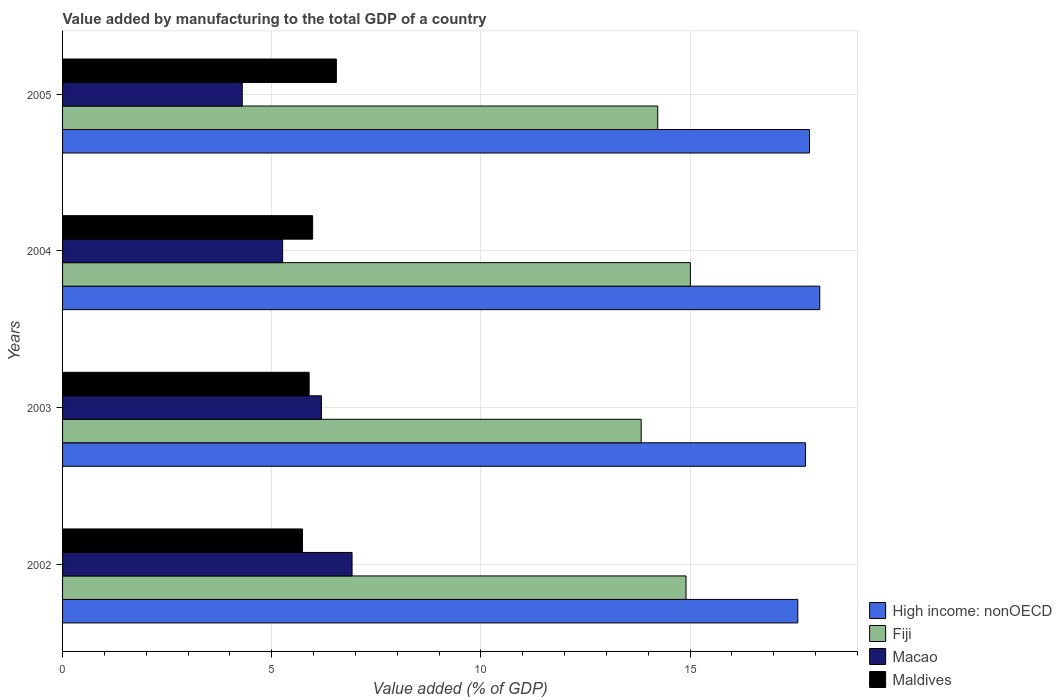How many different coloured bars are there?
Provide a succinct answer. 4. Are the number of bars per tick equal to the number of legend labels?
Your answer should be compact. Yes. Are the number of bars on each tick of the Y-axis equal?
Offer a very short reply. Yes. How many bars are there on the 1st tick from the top?
Provide a short and direct response. 4. How many bars are there on the 1st tick from the bottom?
Provide a short and direct response. 4. What is the value added by manufacturing to the total GDP in Maldives in 2005?
Provide a short and direct response. 6.54. Across all years, what is the maximum value added by manufacturing to the total GDP in Maldives?
Your response must be concise. 6.54. Across all years, what is the minimum value added by manufacturing to the total GDP in Fiji?
Ensure brevity in your answer.  13.83. In which year was the value added by manufacturing to the total GDP in Macao minimum?
Make the answer very short. 2005. What is the total value added by manufacturing to the total GDP in Fiji in the graph?
Your answer should be very brief. 57.97. What is the difference between the value added by manufacturing to the total GDP in Maldives in 2002 and that in 2003?
Ensure brevity in your answer.  -0.16. What is the difference between the value added by manufacturing to the total GDP in High income: nonOECD in 2003 and the value added by manufacturing to the total GDP in Maldives in 2002?
Give a very brief answer. 12.03. What is the average value added by manufacturing to the total GDP in Maldives per year?
Offer a very short reply. 6.04. In the year 2003, what is the difference between the value added by manufacturing to the total GDP in High income: nonOECD and value added by manufacturing to the total GDP in Macao?
Your answer should be very brief. 11.57. In how many years, is the value added by manufacturing to the total GDP in High income: nonOECD greater than 17 %?
Ensure brevity in your answer.  4. What is the ratio of the value added by manufacturing to the total GDP in Maldives in 2003 to that in 2004?
Your answer should be very brief. 0.99. Is the value added by manufacturing to the total GDP in High income: nonOECD in 2003 less than that in 2005?
Offer a terse response. Yes. What is the difference between the highest and the second highest value added by manufacturing to the total GDP in Macao?
Keep it short and to the point. 0.73. What is the difference between the highest and the lowest value added by manufacturing to the total GDP in Macao?
Give a very brief answer. 2.62. In how many years, is the value added by manufacturing to the total GDP in Maldives greater than the average value added by manufacturing to the total GDP in Maldives taken over all years?
Keep it short and to the point. 1. What does the 3rd bar from the top in 2005 represents?
Make the answer very short. Fiji. What does the 3rd bar from the bottom in 2003 represents?
Your response must be concise. Macao. Are all the bars in the graph horizontal?
Your response must be concise. Yes. How many years are there in the graph?
Your answer should be compact. 4. Are the values on the major ticks of X-axis written in scientific E-notation?
Provide a short and direct response. No. Does the graph contain any zero values?
Provide a short and direct response. No. What is the title of the graph?
Ensure brevity in your answer.  Value added by manufacturing to the total GDP of a country. Does "Turkmenistan" appear as one of the legend labels in the graph?
Your response must be concise. No. What is the label or title of the X-axis?
Provide a short and direct response. Value added (% of GDP). What is the Value added (% of GDP) of High income: nonOECD in 2002?
Make the answer very short. 17.58. What is the Value added (% of GDP) of Fiji in 2002?
Provide a succinct answer. 14.9. What is the Value added (% of GDP) of Macao in 2002?
Give a very brief answer. 6.92. What is the Value added (% of GDP) in Maldives in 2002?
Your answer should be very brief. 5.73. What is the Value added (% of GDP) in High income: nonOECD in 2003?
Make the answer very short. 17.76. What is the Value added (% of GDP) in Fiji in 2003?
Keep it short and to the point. 13.83. What is the Value added (% of GDP) in Macao in 2003?
Offer a terse response. 6.19. What is the Value added (% of GDP) of Maldives in 2003?
Make the answer very short. 5.89. What is the Value added (% of GDP) of High income: nonOECD in 2004?
Your answer should be very brief. 18.1. What is the Value added (% of GDP) in Fiji in 2004?
Your response must be concise. 15.01. What is the Value added (% of GDP) of Macao in 2004?
Your answer should be compact. 5.26. What is the Value added (% of GDP) in Maldives in 2004?
Offer a very short reply. 5.98. What is the Value added (% of GDP) of High income: nonOECD in 2005?
Make the answer very short. 17.86. What is the Value added (% of GDP) of Fiji in 2005?
Offer a terse response. 14.23. What is the Value added (% of GDP) of Macao in 2005?
Offer a terse response. 4.3. What is the Value added (% of GDP) of Maldives in 2005?
Offer a very short reply. 6.54. Across all years, what is the maximum Value added (% of GDP) of High income: nonOECD?
Your response must be concise. 18.1. Across all years, what is the maximum Value added (% of GDP) of Fiji?
Ensure brevity in your answer.  15.01. Across all years, what is the maximum Value added (% of GDP) in Macao?
Your answer should be compact. 6.92. Across all years, what is the maximum Value added (% of GDP) of Maldives?
Your response must be concise. 6.54. Across all years, what is the minimum Value added (% of GDP) in High income: nonOECD?
Offer a very short reply. 17.58. Across all years, what is the minimum Value added (% of GDP) in Fiji?
Offer a very short reply. 13.83. Across all years, what is the minimum Value added (% of GDP) in Macao?
Keep it short and to the point. 4.3. Across all years, what is the minimum Value added (% of GDP) of Maldives?
Your response must be concise. 5.73. What is the total Value added (% of GDP) in High income: nonOECD in the graph?
Offer a very short reply. 71.29. What is the total Value added (% of GDP) of Fiji in the graph?
Ensure brevity in your answer.  57.97. What is the total Value added (% of GDP) of Macao in the graph?
Provide a succinct answer. 22.66. What is the total Value added (% of GDP) of Maldives in the graph?
Make the answer very short. 24.15. What is the difference between the Value added (% of GDP) of High income: nonOECD in 2002 and that in 2003?
Your answer should be very brief. -0.18. What is the difference between the Value added (% of GDP) in Fiji in 2002 and that in 2003?
Offer a very short reply. 1.07. What is the difference between the Value added (% of GDP) of Macao in 2002 and that in 2003?
Keep it short and to the point. 0.73. What is the difference between the Value added (% of GDP) of Maldives in 2002 and that in 2003?
Your answer should be very brief. -0.16. What is the difference between the Value added (% of GDP) of High income: nonOECD in 2002 and that in 2004?
Offer a very short reply. -0.52. What is the difference between the Value added (% of GDP) of Fiji in 2002 and that in 2004?
Your answer should be compact. -0.1. What is the difference between the Value added (% of GDP) in Macao in 2002 and that in 2004?
Ensure brevity in your answer.  1.66. What is the difference between the Value added (% of GDP) of Maldives in 2002 and that in 2004?
Ensure brevity in your answer.  -0.24. What is the difference between the Value added (% of GDP) of High income: nonOECD in 2002 and that in 2005?
Your response must be concise. -0.28. What is the difference between the Value added (% of GDP) of Fiji in 2002 and that in 2005?
Provide a short and direct response. 0.68. What is the difference between the Value added (% of GDP) in Macao in 2002 and that in 2005?
Offer a terse response. 2.62. What is the difference between the Value added (% of GDP) of Maldives in 2002 and that in 2005?
Make the answer very short. -0.81. What is the difference between the Value added (% of GDP) in High income: nonOECD in 2003 and that in 2004?
Offer a very short reply. -0.34. What is the difference between the Value added (% of GDP) in Fiji in 2003 and that in 2004?
Provide a succinct answer. -1.18. What is the difference between the Value added (% of GDP) of Macao in 2003 and that in 2004?
Keep it short and to the point. 0.93. What is the difference between the Value added (% of GDP) in Maldives in 2003 and that in 2004?
Provide a short and direct response. -0.08. What is the difference between the Value added (% of GDP) of High income: nonOECD in 2003 and that in 2005?
Offer a very short reply. -0.1. What is the difference between the Value added (% of GDP) of Fiji in 2003 and that in 2005?
Make the answer very short. -0.4. What is the difference between the Value added (% of GDP) in Macao in 2003 and that in 2005?
Offer a very short reply. 1.89. What is the difference between the Value added (% of GDP) of Maldives in 2003 and that in 2005?
Ensure brevity in your answer.  -0.65. What is the difference between the Value added (% of GDP) of High income: nonOECD in 2004 and that in 2005?
Give a very brief answer. 0.24. What is the difference between the Value added (% of GDP) in Fiji in 2004 and that in 2005?
Your response must be concise. 0.78. What is the difference between the Value added (% of GDP) of Macao in 2004 and that in 2005?
Your answer should be very brief. 0.97. What is the difference between the Value added (% of GDP) in Maldives in 2004 and that in 2005?
Keep it short and to the point. -0.57. What is the difference between the Value added (% of GDP) in High income: nonOECD in 2002 and the Value added (% of GDP) in Fiji in 2003?
Keep it short and to the point. 3.74. What is the difference between the Value added (% of GDP) of High income: nonOECD in 2002 and the Value added (% of GDP) of Macao in 2003?
Offer a very short reply. 11.39. What is the difference between the Value added (% of GDP) of High income: nonOECD in 2002 and the Value added (% of GDP) of Maldives in 2003?
Provide a succinct answer. 11.68. What is the difference between the Value added (% of GDP) in Fiji in 2002 and the Value added (% of GDP) in Macao in 2003?
Provide a succinct answer. 8.72. What is the difference between the Value added (% of GDP) in Fiji in 2002 and the Value added (% of GDP) in Maldives in 2003?
Offer a terse response. 9.01. What is the difference between the Value added (% of GDP) of Macao in 2002 and the Value added (% of GDP) of Maldives in 2003?
Make the answer very short. 1.03. What is the difference between the Value added (% of GDP) of High income: nonOECD in 2002 and the Value added (% of GDP) of Fiji in 2004?
Ensure brevity in your answer.  2.57. What is the difference between the Value added (% of GDP) in High income: nonOECD in 2002 and the Value added (% of GDP) in Macao in 2004?
Offer a very short reply. 12.31. What is the difference between the Value added (% of GDP) of High income: nonOECD in 2002 and the Value added (% of GDP) of Maldives in 2004?
Your answer should be compact. 11.6. What is the difference between the Value added (% of GDP) of Fiji in 2002 and the Value added (% of GDP) of Macao in 2004?
Your response must be concise. 9.64. What is the difference between the Value added (% of GDP) in Fiji in 2002 and the Value added (% of GDP) in Maldives in 2004?
Make the answer very short. 8.93. What is the difference between the Value added (% of GDP) in Macao in 2002 and the Value added (% of GDP) in Maldives in 2004?
Your answer should be compact. 0.94. What is the difference between the Value added (% of GDP) in High income: nonOECD in 2002 and the Value added (% of GDP) in Fiji in 2005?
Ensure brevity in your answer.  3.35. What is the difference between the Value added (% of GDP) of High income: nonOECD in 2002 and the Value added (% of GDP) of Macao in 2005?
Your answer should be compact. 13.28. What is the difference between the Value added (% of GDP) of High income: nonOECD in 2002 and the Value added (% of GDP) of Maldives in 2005?
Provide a succinct answer. 11.03. What is the difference between the Value added (% of GDP) in Fiji in 2002 and the Value added (% of GDP) in Macao in 2005?
Your answer should be very brief. 10.61. What is the difference between the Value added (% of GDP) in Fiji in 2002 and the Value added (% of GDP) in Maldives in 2005?
Make the answer very short. 8.36. What is the difference between the Value added (% of GDP) in Macao in 2002 and the Value added (% of GDP) in Maldives in 2005?
Your response must be concise. 0.38. What is the difference between the Value added (% of GDP) in High income: nonOECD in 2003 and the Value added (% of GDP) in Fiji in 2004?
Provide a succinct answer. 2.75. What is the difference between the Value added (% of GDP) of High income: nonOECD in 2003 and the Value added (% of GDP) of Macao in 2004?
Provide a succinct answer. 12.5. What is the difference between the Value added (% of GDP) of High income: nonOECD in 2003 and the Value added (% of GDP) of Maldives in 2004?
Your response must be concise. 11.78. What is the difference between the Value added (% of GDP) of Fiji in 2003 and the Value added (% of GDP) of Macao in 2004?
Your answer should be very brief. 8.57. What is the difference between the Value added (% of GDP) in Fiji in 2003 and the Value added (% of GDP) in Maldives in 2004?
Keep it short and to the point. 7.85. What is the difference between the Value added (% of GDP) of Macao in 2003 and the Value added (% of GDP) of Maldives in 2004?
Your answer should be compact. 0.21. What is the difference between the Value added (% of GDP) in High income: nonOECD in 2003 and the Value added (% of GDP) in Fiji in 2005?
Offer a very short reply. 3.53. What is the difference between the Value added (% of GDP) of High income: nonOECD in 2003 and the Value added (% of GDP) of Macao in 2005?
Ensure brevity in your answer.  13.46. What is the difference between the Value added (% of GDP) in High income: nonOECD in 2003 and the Value added (% of GDP) in Maldives in 2005?
Make the answer very short. 11.21. What is the difference between the Value added (% of GDP) in Fiji in 2003 and the Value added (% of GDP) in Macao in 2005?
Keep it short and to the point. 9.54. What is the difference between the Value added (% of GDP) of Fiji in 2003 and the Value added (% of GDP) of Maldives in 2005?
Give a very brief answer. 7.29. What is the difference between the Value added (% of GDP) in Macao in 2003 and the Value added (% of GDP) in Maldives in 2005?
Offer a very short reply. -0.36. What is the difference between the Value added (% of GDP) of High income: nonOECD in 2004 and the Value added (% of GDP) of Fiji in 2005?
Make the answer very short. 3.87. What is the difference between the Value added (% of GDP) of High income: nonOECD in 2004 and the Value added (% of GDP) of Macao in 2005?
Make the answer very short. 13.8. What is the difference between the Value added (% of GDP) in High income: nonOECD in 2004 and the Value added (% of GDP) in Maldives in 2005?
Your answer should be compact. 11.56. What is the difference between the Value added (% of GDP) in Fiji in 2004 and the Value added (% of GDP) in Macao in 2005?
Provide a succinct answer. 10.71. What is the difference between the Value added (% of GDP) of Fiji in 2004 and the Value added (% of GDP) of Maldives in 2005?
Your answer should be very brief. 8.46. What is the difference between the Value added (% of GDP) in Macao in 2004 and the Value added (% of GDP) in Maldives in 2005?
Provide a succinct answer. -1.28. What is the average Value added (% of GDP) of High income: nonOECD per year?
Your answer should be compact. 17.82. What is the average Value added (% of GDP) of Fiji per year?
Offer a terse response. 14.49. What is the average Value added (% of GDP) in Macao per year?
Your answer should be very brief. 5.67. What is the average Value added (% of GDP) in Maldives per year?
Keep it short and to the point. 6.04. In the year 2002, what is the difference between the Value added (% of GDP) of High income: nonOECD and Value added (% of GDP) of Fiji?
Provide a succinct answer. 2.67. In the year 2002, what is the difference between the Value added (% of GDP) of High income: nonOECD and Value added (% of GDP) of Macao?
Your answer should be very brief. 10.65. In the year 2002, what is the difference between the Value added (% of GDP) in High income: nonOECD and Value added (% of GDP) in Maldives?
Provide a short and direct response. 11.84. In the year 2002, what is the difference between the Value added (% of GDP) in Fiji and Value added (% of GDP) in Macao?
Your answer should be very brief. 7.98. In the year 2002, what is the difference between the Value added (% of GDP) in Fiji and Value added (% of GDP) in Maldives?
Make the answer very short. 9.17. In the year 2002, what is the difference between the Value added (% of GDP) of Macao and Value added (% of GDP) of Maldives?
Provide a short and direct response. 1.19. In the year 2003, what is the difference between the Value added (% of GDP) of High income: nonOECD and Value added (% of GDP) of Fiji?
Make the answer very short. 3.93. In the year 2003, what is the difference between the Value added (% of GDP) of High income: nonOECD and Value added (% of GDP) of Macao?
Your answer should be compact. 11.57. In the year 2003, what is the difference between the Value added (% of GDP) in High income: nonOECD and Value added (% of GDP) in Maldives?
Your response must be concise. 11.87. In the year 2003, what is the difference between the Value added (% of GDP) of Fiji and Value added (% of GDP) of Macao?
Offer a terse response. 7.64. In the year 2003, what is the difference between the Value added (% of GDP) in Fiji and Value added (% of GDP) in Maldives?
Your response must be concise. 7.94. In the year 2003, what is the difference between the Value added (% of GDP) of Macao and Value added (% of GDP) of Maldives?
Offer a very short reply. 0.29. In the year 2004, what is the difference between the Value added (% of GDP) of High income: nonOECD and Value added (% of GDP) of Fiji?
Give a very brief answer. 3.09. In the year 2004, what is the difference between the Value added (% of GDP) of High income: nonOECD and Value added (% of GDP) of Macao?
Offer a terse response. 12.84. In the year 2004, what is the difference between the Value added (% of GDP) of High income: nonOECD and Value added (% of GDP) of Maldives?
Offer a very short reply. 12.12. In the year 2004, what is the difference between the Value added (% of GDP) in Fiji and Value added (% of GDP) in Macao?
Keep it short and to the point. 9.75. In the year 2004, what is the difference between the Value added (% of GDP) in Fiji and Value added (% of GDP) in Maldives?
Ensure brevity in your answer.  9.03. In the year 2004, what is the difference between the Value added (% of GDP) in Macao and Value added (% of GDP) in Maldives?
Keep it short and to the point. -0.72. In the year 2005, what is the difference between the Value added (% of GDP) in High income: nonOECD and Value added (% of GDP) in Fiji?
Ensure brevity in your answer.  3.63. In the year 2005, what is the difference between the Value added (% of GDP) of High income: nonOECD and Value added (% of GDP) of Macao?
Provide a succinct answer. 13.56. In the year 2005, what is the difference between the Value added (% of GDP) of High income: nonOECD and Value added (% of GDP) of Maldives?
Your answer should be compact. 11.31. In the year 2005, what is the difference between the Value added (% of GDP) of Fiji and Value added (% of GDP) of Macao?
Keep it short and to the point. 9.93. In the year 2005, what is the difference between the Value added (% of GDP) of Fiji and Value added (% of GDP) of Maldives?
Offer a terse response. 7.68. In the year 2005, what is the difference between the Value added (% of GDP) in Macao and Value added (% of GDP) in Maldives?
Provide a succinct answer. -2.25. What is the ratio of the Value added (% of GDP) of High income: nonOECD in 2002 to that in 2003?
Offer a very short reply. 0.99. What is the ratio of the Value added (% of GDP) of Fiji in 2002 to that in 2003?
Provide a succinct answer. 1.08. What is the ratio of the Value added (% of GDP) of Macao in 2002 to that in 2003?
Your response must be concise. 1.12. What is the ratio of the Value added (% of GDP) in Maldives in 2002 to that in 2003?
Give a very brief answer. 0.97. What is the ratio of the Value added (% of GDP) of High income: nonOECD in 2002 to that in 2004?
Make the answer very short. 0.97. What is the ratio of the Value added (% of GDP) in Fiji in 2002 to that in 2004?
Ensure brevity in your answer.  0.99. What is the ratio of the Value added (% of GDP) of Macao in 2002 to that in 2004?
Provide a short and direct response. 1.32. What is the ratio of the Value added (% of GDP) in Maldives in 2002 to that in 2004?
Make the answer very short. 0.96. What is the ratio of the Value added (% of GDP) of High income: nonOECD in 2002 to that in 2005?
Your response must be concise. 0.98. What is the ratio of the Value added (% of GDP) of Fiji in 2002 to that in 2005?
Offer a very short reply. 1.05. What is the ratio of the Value added (% of GDP) of Macao in 2002 to that in 2005?
Keep it short and to the point. 1.61. What is the ratio of the Value added (% of GDP) of Maldives in 2002 to that in 2005?
Ensure brevity in your answer.  0.88. What is the ratio of the Value added (% of GDP) in High income: nonOECD in 2003 to that in 2004?
Provide a short and direct response. 0.98. What is the ratio of the Value added (% of GDP) of Fiji in 2003 to that in 2004?
Make the answer very short. 0.92. What is the ratio of the Value added (% of GDP) of Macao in 2003 to that in 2004?
Provide a short and direct response. 1.18. What is the ratio of the Value added (% of GDP) in Maldives in 2003 to that in 2004?
Give a very brief answer. 0.99. What is the ratio of the Value added (% of GDP) of High income: nonOECD in 2003 to that in 2005?
Your answer should be very brief. 0.99. What is the ratio of the Value added (% of GDP) of Fiji in 2003 to that in 2005?
Offer a very short reply. 0.97. What is the ratio of the Value added (% of GDP) in Macao in 2003 to that in 2005?
Offer a very short reply. 1.44. What is the ratio of the Value added (% of GDP) in Maldives in 2003 to that in 2005?
Your response must be concise. 0.9. What is the ratio of the Value added (% of GDP) in High income: nonOECD in 2004 to that in 2005?
Provide a short and direct response. 1.01. What is the ratio of the Value added (% of GDP) in Fiji in 2004 to that in 2005?
Your answer should be very brief. 1.05. What is the ratio of the Value added (% of GDP) of Macao in 2004 to that in 2005?
Offer a terse response. 1.22. What is the ratio of the Value added (% of GDP) of Maldives in 2004 to that in 2005?
Your response must be concise. 0.91. What is the difference between the highest and the second highest Value added (% of GDP) in High income: nonOECD?
Provide a succinct answer. 0.24. What is the difference between the highest and the second highest Value added (% of GDP) of Fiji?
Offer a very short reply. 0.1. What is the difference between the highest and the second highest Value added (% of GDP) in Macao?
Keep it short and to the point. 0.73. What is the difference between the highest and the second highest Value added (% of GDP) in Maldives?
Keep it short and to the point. 0.57. What is the difference between the highest and the lowest Value added (% of GDP) in High income: nonOECD?
Make the answer very short. 0.52. What is the difference between the highest and the lowest Value added (% of GDP) of Fiji?
Ensure brevity in your answer.  1.18. What is the difference between the highest and the lowest Value added (% of GDP) of Macao?
Provide a succinct answer. 2.62. What is the difference between the highest and the lowest Value added (% of GDP) in Maldives?
Offer a terse response. 0.81. 